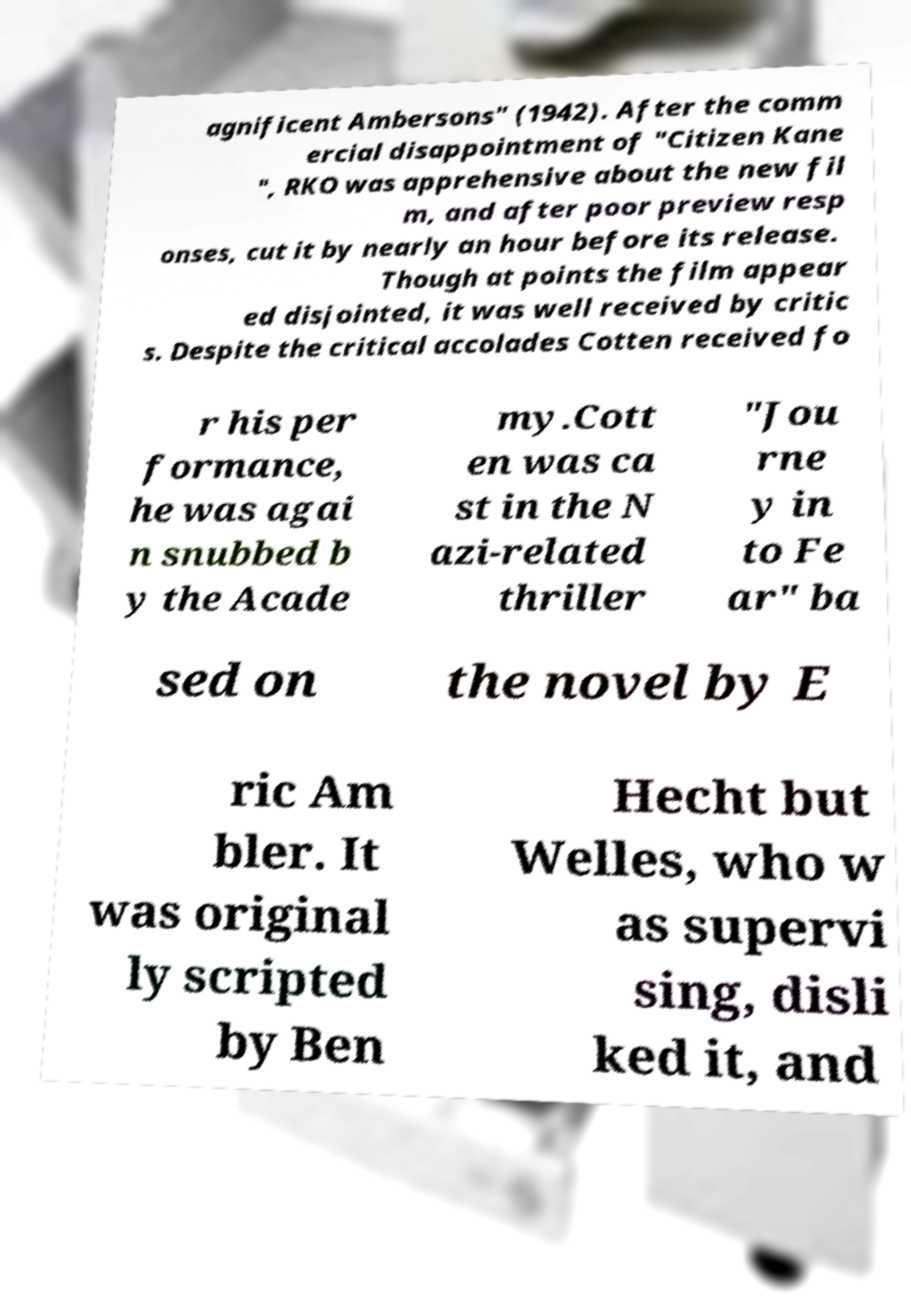What messages or text are displayed in this image? I need them in a readable, typed format. agnificent Ambersons" (1942). After the comm ercial disappointment of "Citizen Kane ", RKO was apprehensive about the new fil m, and after poor preview resp onses, cut it by nearly an hour before its release. Though at points the film appear ed disjointed, it was well received by critic s. Despite the critical accolades Cotten received fo r his per formance, he was agai n snubbed b y the Acade my.Cott en was ca st in the N azi-related thriller "Jou rne y in to Fe ar" ba sed on the novel by E ric Am bler. It was original ly scripted by Ben Hecht but Welles, who w as supervi sing, disli ked it, and 